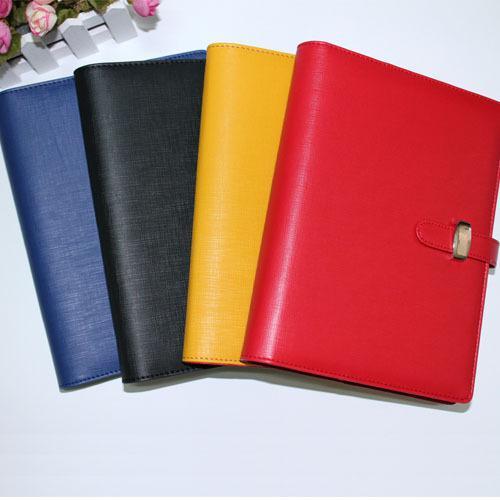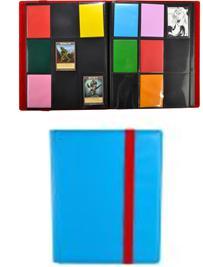The first image is the image on the left, the second image is the image on the right. Considering the images on both sides, is "Only one folder is on the left image." valid? Answer yes or no. No. 